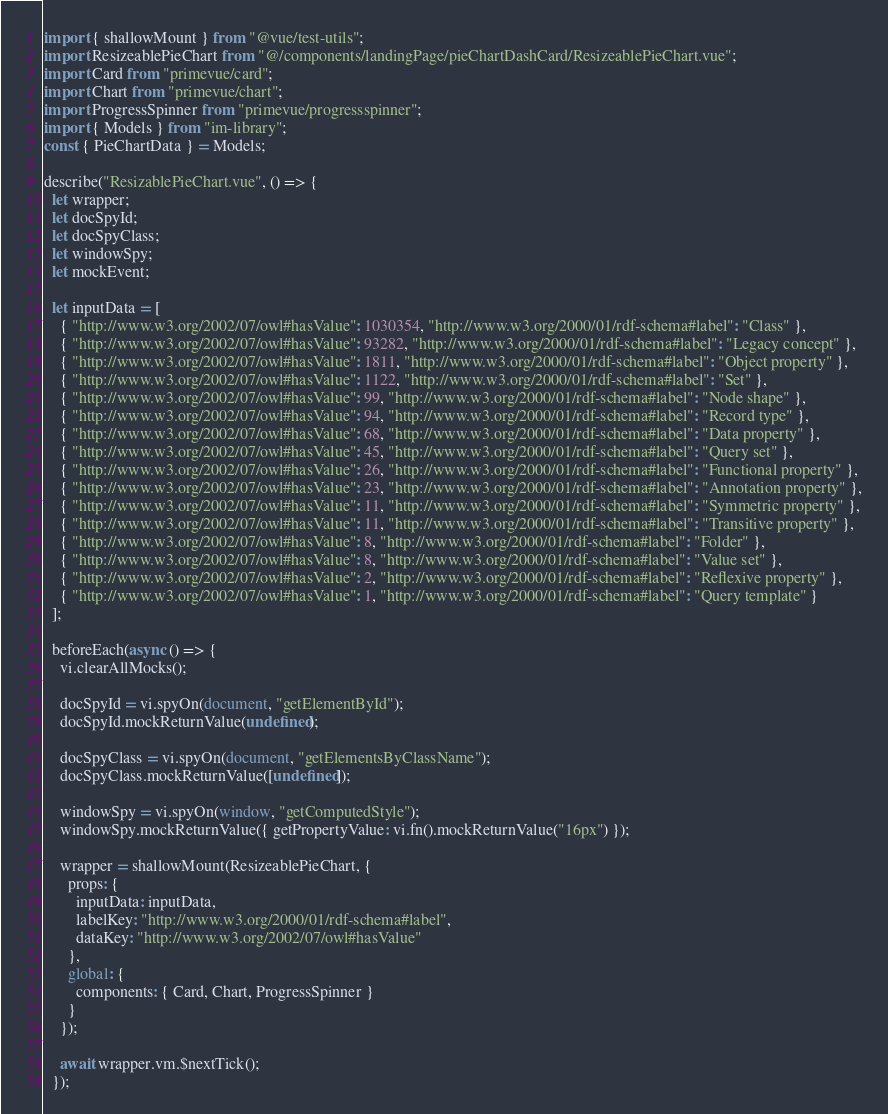Convert code to text. <code><loc_0><loc_0><loc_500><loc_500><_JavaScript_>import { shallowMount } from "@vue/test-utils";
import ResizeablePieChart from "@/components/landingPage/pieChartDashCard/ResizeablePieChart.vue";
import Card from "primevue/card";
import Chart from "primevue/chart";
import ProgressSpinner from "primevue/progressspinner";
import { Models } from "im-library";
const { PieChartData } = Models;

describe("ResizablePieChart.vue", () => {
  let wrapper;
  let docSpyId;
  let docSpyClass;
  let windowSpy;
  let mockEvent;

  let inputData = [
    { "http://www.w3.org/2002/07/owl#hasValue": 1030354, "http://www.w3.org/2000/01/rdf-schema#label": "Class" },
    { "http://www.w3.org/2002/07/owl#hasValue": 93282, "http://www.w3.org/2000/01/rdf-schema#label": "Legacy concept" },
    { "http://www.w3.org/2002/07/owl#hasValue": 1811, "http://www.w3.org/2000/01/rdf-schema#label": "Object property" },
    { "http://www.w3.org/2002/07/owl#hasValue": 1122, "http://www.w3.org/2000/01/rdf-schema#label": "Set" },
    { "http://www.w3.org/2002/07/owl#hasValue": 99, "http://www.w3.org/2000/01/rdf-schema#label": "Node shape" },
    { "http://www.w3.org/2002/07/owl#hasValue": 94, "http://www.w3.org/2000/01/rdf-schema#label": "Record type" },
    { "http://www.w3.org/2002/07/owl#hasValue": 68, "http://www.w3.org/2000/01/rdf-schema#label": "Data property" },
    { "http://www.w3.org/2002/07/owl#hasValue": 45, "http://www.w3.org/2000/01/rdf-schema#label": "Query set" },
    { "http://www.w3.org/2002/07/owl#hasValue": 26, "http://www.w3.org/2000/01/rdf-schema#label": "Functional property" },
    { "http://www.w3.org/2002/07/owl#hasValue": 23, "http://www.w3.org/2000/01/rdf-schema#label": "Annotation property" },
    { "http://www.w3.org/2002/07/owl#hasValue": 11, "http://www.w3.org/2000/01/rdf-schema#label": "Symmetric property" },
    { "http://www.w3.org/2002/07/owl#hasValue": 11, "http://www.w3.org/2000/01/rdf-schema#label": "Transitive property" },
    { "http://www.w3.org/2002/07/owl#hasValue": 8, "http://www.w3.org/2000/01/rdf-schema#label": "Folder" },
    { "http://www.w3.org/2002/07/owl#hasValue": 8, "http://www.w3.org/2000/01/rdf-schema#label": "Value set" },
    { "http://www.w3.org/2002/07/owl#hasValue": 2, "http://www.w3.org/2000/01/rdf-schema#label": "Reflexive property" },
    { "http://www.w3.org/2002/07/owl#hasValue": 1, "http://www.w3.org/2000/01/rdf-schema#label": "Query template" }
  ];

  beforeEach(async () => {
    vi.clearAllMocks();

    docSpyId = vi.spyOn(document, "getElementById");
    docSpyId.mockReturnValue(undefined);

    docSpyClass = vi.spyOn(document, "getElementsByClassName");
    docSpyClass.mockReturnValue([undefined]);

    windowSpy = vi.spyOn(window, "getComputedStyle");
    windowSpy.mockReturnValue({ getPropertyValue: vi.fn().mockReturnValue("16px") });

    wrapper = shallowMount(ResizeablePieChart, {
      props: {
        inputData: inputData,
        labelKey: "http://www.w3.org/2000/01/rdf-schema#label",
        dataKey: "http://www.w3.org/2002/07/owl#hasValue"
      },
      global: {
        components: { Card, Chart, ProgressSpinner }
      }
    });

    await wrapper.vm.$nextTick();
  });
</code> 